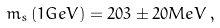Convert formula to latex. <formula><loc_0><loc_0><loc_500><loc_500>m _ { s } \, ( 1 G e V ) = 2 0 3 \pm 2 0 M e V \, ,</formula> 